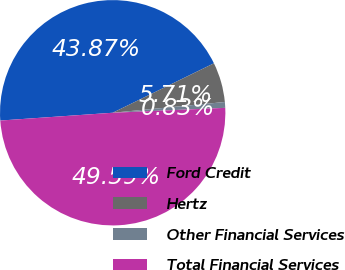Convert chart to OTSL. <chart><loc_0><loc_0><loc_500><loc_500><pie_chart><fcel>Ford Credit<fcel>Hertz<fcel>Other Financial Services<fcel>Total Financial Services<nl><fcel>43.87%<fcel>5.71%<fcel>0.83%<fcel>49.59%<nl></chart> 